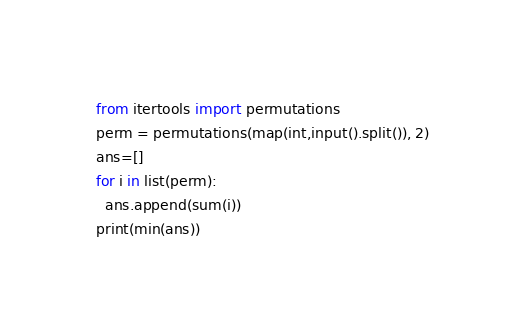<code> <loc_0><loc_0><loc_500><loc_500><_Python_>from itertools import permutations 
perm = permutations(map(int,input().split()), 2) 
ans=[]
for i in list(perm): 
  ans.append(sum(i))
print(min(ans))</code> 